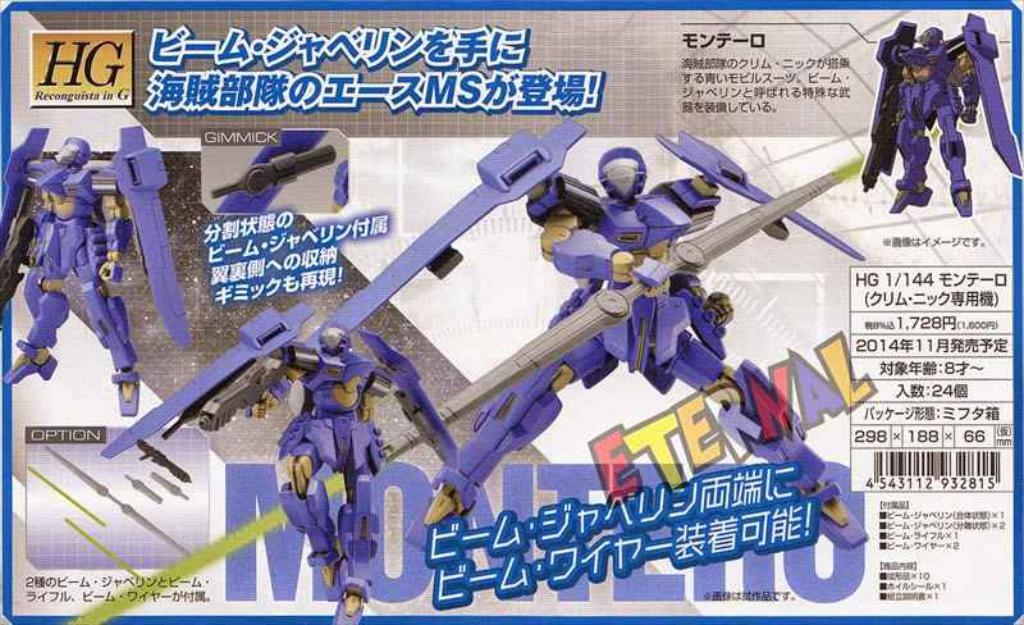What is the main subject of the image? There is an advertisement in the image. What type of objects are featured in the advertisement? The advertisement contains robots. Is there any text present in the advertisement? Yes, there is text present in the advertisement. Can you see any waves in the image? There are no waves present in the image; it features an advertisement with robots and text. What type of cracker is being advertised in the image? There is no cracker being advertised in the image; it features robots and text related to an unspecified product or service. 